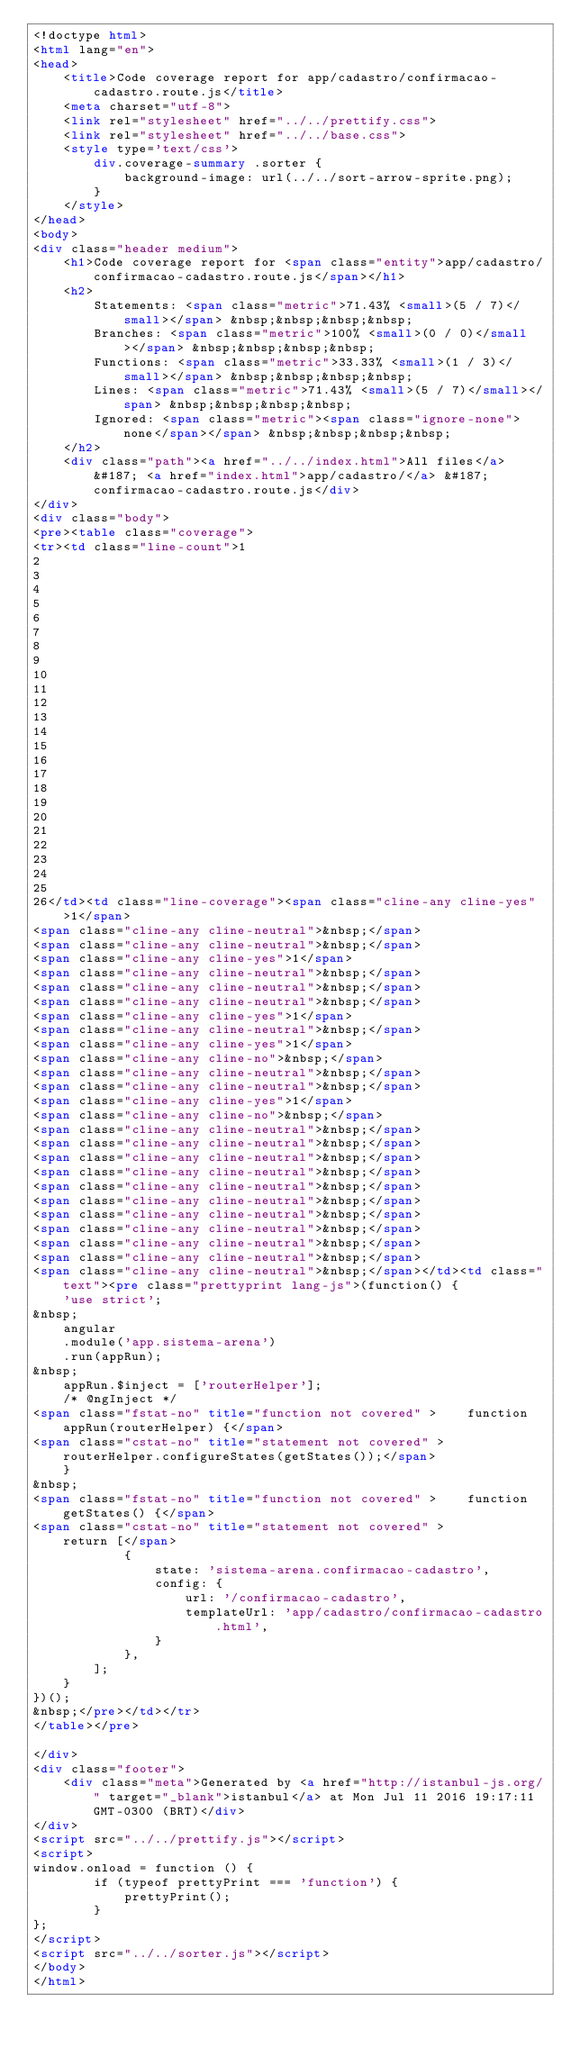Convert code to text. <code><loc_0><loc_0><loc_500><loc_500><_HTML_><!doctype html>
<html lang="en">
<head>
    <title>Code coverage report for app/cadastro/confirmacao-cadastro.route.js</title>
    <meta charset="utf-8">
    <link rel="stylesheet" href="../../prettify.css">
    <link rel="stylesheet" href="../../base.css">
    <style type='text/css'>
        div.coverage-summary .sorter {
            background-image: url(../../sort-arrow-sprite.png);
        }
    </style>
</head>
<body>
<div class="header medium">
    <h1>Code coverage report for <span class="entity">app/cadastro/confirmacao-cadastro.route.js</span></h1>
    <h2>
        Statements: <span class="metric">71.43% <small>(5 / 7)</small></span> &nbsp;&nbsp;&nbsp;&nbsp;
        Branches: <span class="metric">100% <small>(0 / 0)</small></span> &nbsp;&nbsp;&nbsp;&nbsp;
        Functions: <span class="metric">33.33% <small>(1 / 3)</small></span> &nbsp;&nbsp;&nbsp;&nbsp;
        Lines: <span class="metric">71.43% <small>(5 / 7)</small></span> &nbsp;&nbsp;&nbsp;&nbsp;
        Ignored: <span class="metric"><span class="ignore-none">none</span></span> &nbsp;&nbsp;&nbsp;&nbsp;
    </h2>
    <div class="path"><a href="../../index.html">All files</a> &#187; <a href="index.html">app/cadastro/</a> &#187; confirmacao-cadastro.route.js</div>
</div>
<div class="body">
<pre><table class="coverage">
<tr><td class="line-count">1
2
3
4
5
6
7
8
9
10
11
12
13
14
15
16
17
18
19
20
21
22
23
24
25
26</td><td class="line-coverage"><span class="cline-any cline-yes">1</span>
<span class="cline-any cline-neutral">&nbsp;</span>
<span class="cline-any cline-neutral">&nbsp;</span>
<span class="cline-any cline-yes">1</span>
<span class="cline-any cline-neutral">&nbsp;</span>
<span class="cline-any cline-neutral">&nbsp;</span>
<span class="cline-any cline-neutral">&nbsp;</span>
<span class="cline-any cline-yes">1</span>
<span class="cline-any cline-neutral">&nbsp;</span>
<span class="cline-any cline-yes">1</span>
<span class="cline-any cline-no">&nbsp;</span>
<span class="cline-any cline-neutral">&nbsp;</span>
<span class="cline-any cline-neutral">&nbsp;</span>
<span class="cline-any cline-yes">1</span>
<span class="cline-any cline-no">&nbsp;</span>
<span class="cline-any cline-neutral">&nbsp;</span>
<span class="cline-any cline-neutral">&nbsp;</span>
<span class="cline-any cline-neutral">&nbsp;</span>
<span class="cline-any cline-neutral">&nbsp;</span>
<span class="cline-any cline-neutral">&nbsp;</span>
<span class="cline-any cline-neutral">&nbsp;</span>
<span class="cline-any cline-neutral">&nbsp;</span>
<span class="cline-any cline-neutral">&nbsp;</span>
<span class="cline-any cline-neutral">&nbsp;</span>
<span class="cline-any cline-neutral">&nbsp;</span>
<span class="cline-any cline-neutral">&nbsp;</span></td><td class="text"><pre class="prettyprint lang-js">(function() {
    'use strict';
&nbsp;
    angular
    .module('app.sistema-arena')
    .run(appRun);
&nbsp;
    appRun.$inject = ['routerHelper'];
    /* @ngInject */
<span class="fstat-no" title="function not covered" >    function appRun(routerHelper) {</span>
<span class="cstat-no" title="statement not covered" >        routerHelper.configureStates(getStates());</span>
    }
&nbsp;
<span class="fstat-no" title="function not covered" >    function getStates() {</span>
<span class="cstat-no" title="statement not covered" >        return [</span>
            {
                state: 'sistema-arena.confirmacao-cadastro',
                config: {
                    url: '/confirmacao-cadastro',
                    templateUrl: 'app/cadastro/confirmacao-cadastro.html',
                }
            },
        ];
    }
})();
&nbsp;</pre></td></tr>
</table></pre>

</div>
<div class="footer">
    <div class="meta">Generated by <a href="http://istanbul-js.org/" target="_blank">istanbul</a> at Mon Jul 11 2016 19:17:11 GMT-0300 (BRT)</div>
</div>
<script src="../../prettify.js"></script>
<script>
window.onload = function () {
        if (typeof prettyPrint === 'function') {
            prettyPrint();
        }
};
</script>
<script src="../../sorter.js"></script>
</body>
</html>
</code> 